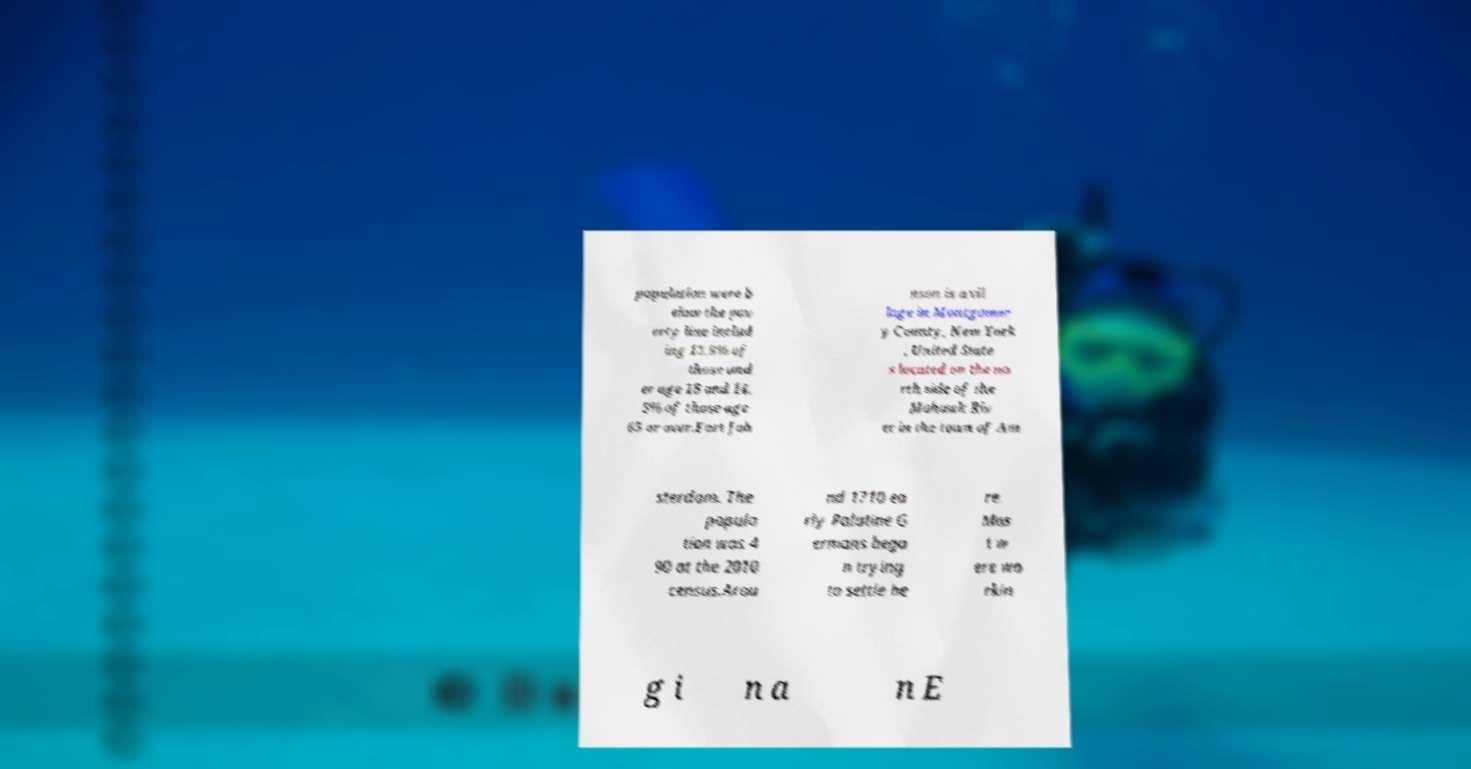Can you read and provide the text displayed in the image?This photo seems to have some interesting text. Can you extract and type it out for me? population were b elow the pov erty line includ ing 13.9% of those und er age 18 and 14. 5% of those age 65 or over.Fort Joh nson is a vil lage in Montgomer y County, New York , United State s located on the no rth side of the Mohawk Riv er in the town of Am sterdam. The popula tion was 4 90 at the 2010 census.Arou nd 1710 ea rly Palatine G ermans bega n trying to settle he re. Mos t w ere wo rkin g i n a n E 